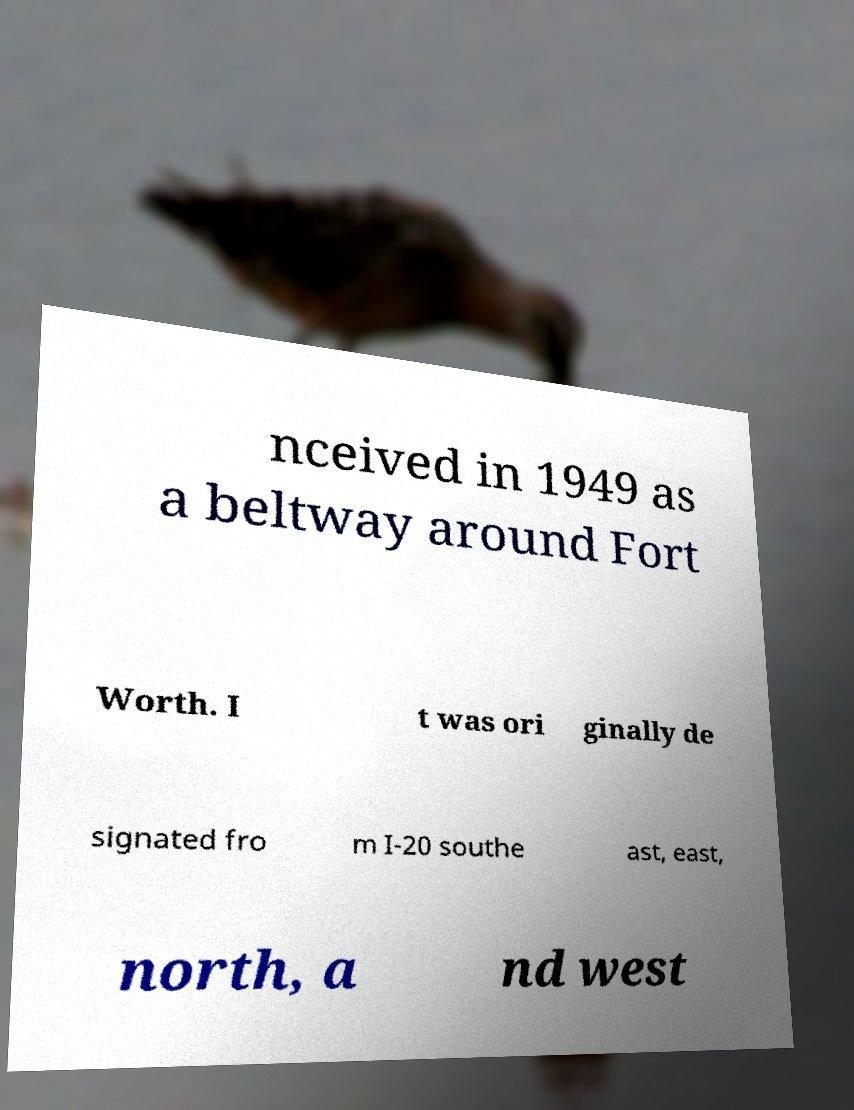I need the written content from this picture converted into text. Can you do that? nceived in 1949 as a beltway around Fort Worth. I t was ori ginally de signated fro m I-20 southe ast, east, north, a nd west 